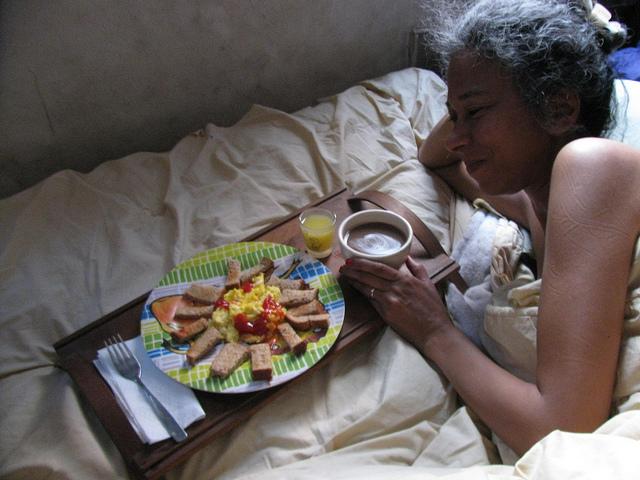What is the woman eating?
Keep it brief. Breakfast. Is this woman married?
Answer briefly. Yes. What color is the woman's hair?
Write a very short answer. Gray. Is the person sleeping?
Concise answer only. No. 